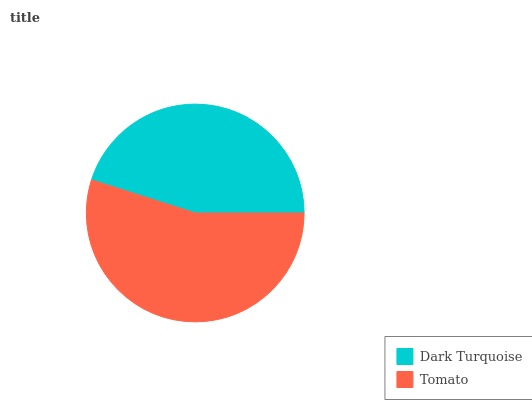Is Dark Turquoise the minimum?
Answer yes or no. Yes. Is Tomato the maximum?
Answer yes or no. Yes. Is Tomato the minimum?
Answer yes or no. No. Is Tomato greater than Dark Turquoise?
Answer yes or no. Yes. Is Dark Turquoise less than Tomato?
Answer yes or no. Yes. Is Dark Turquoise greater than Tomato?
Answer yes or no. No. Is Tomato less than Dark Turquoise?
Answer yes or no. No. Is Tomato the high median?
Answer yes or no. Yes. Is Dark Turquoise the low median?
Answer yes or no. Yes. Is Dark Turquoise the high median?
Answer yes or no. No. Is Tomato the low median?
Answer yes or no. No. 